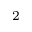<formula> <loc_0><loc_0><loc_500><loc_500>_ { 2 }</formula> 